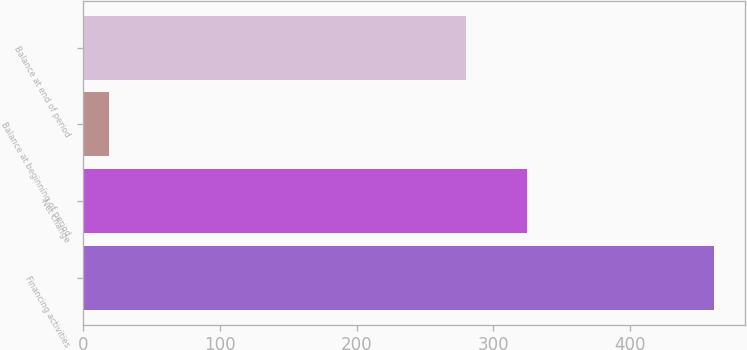Convert chart to OTSL. <chart><loc_0><loc_0><loc_500><loc_500><bar_chart><fcel>Financing activities<fcel>Net change<fcel>Balance at beginning of period<fcel>Balance at end of period<nl><fcel>461<fcel>324.2<fcel>19<fcel>280<nl></chart> 